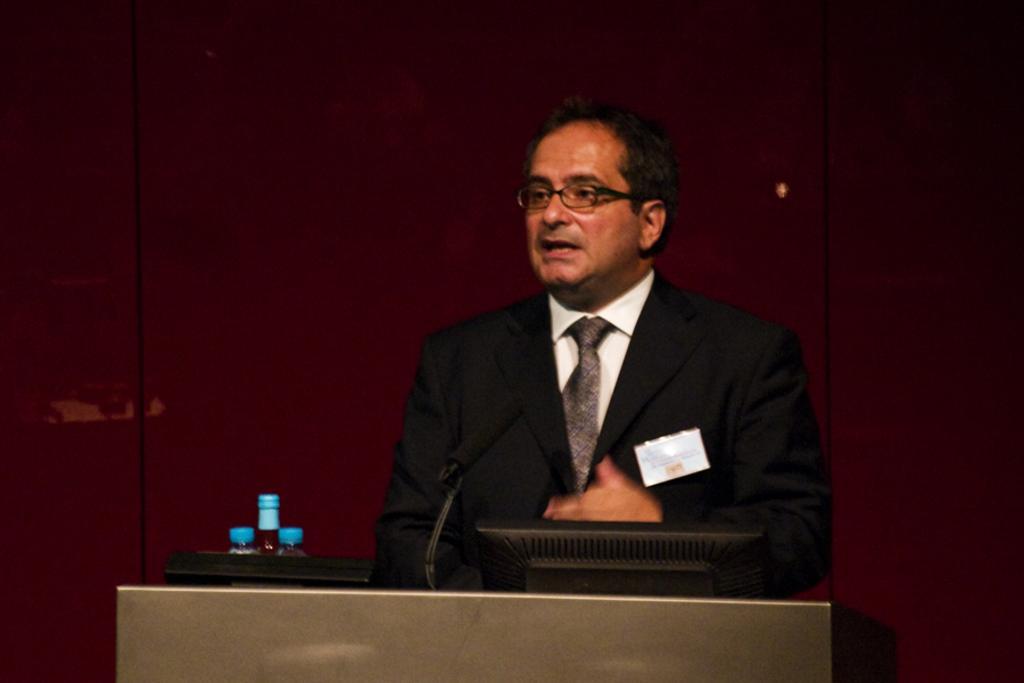In one or two sentences, can you explain what this image depicts? In this image there is a man in the middle. In front of him there is a podium on which there are bottles,mic and a desktop. In the background there is a wall. 